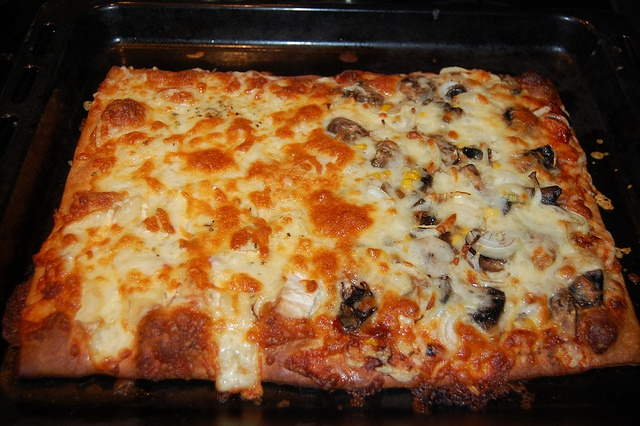Describe the objects in this image and their specific colors. I can see a pizza in black, brown, tan, and maroon tones in this image. 